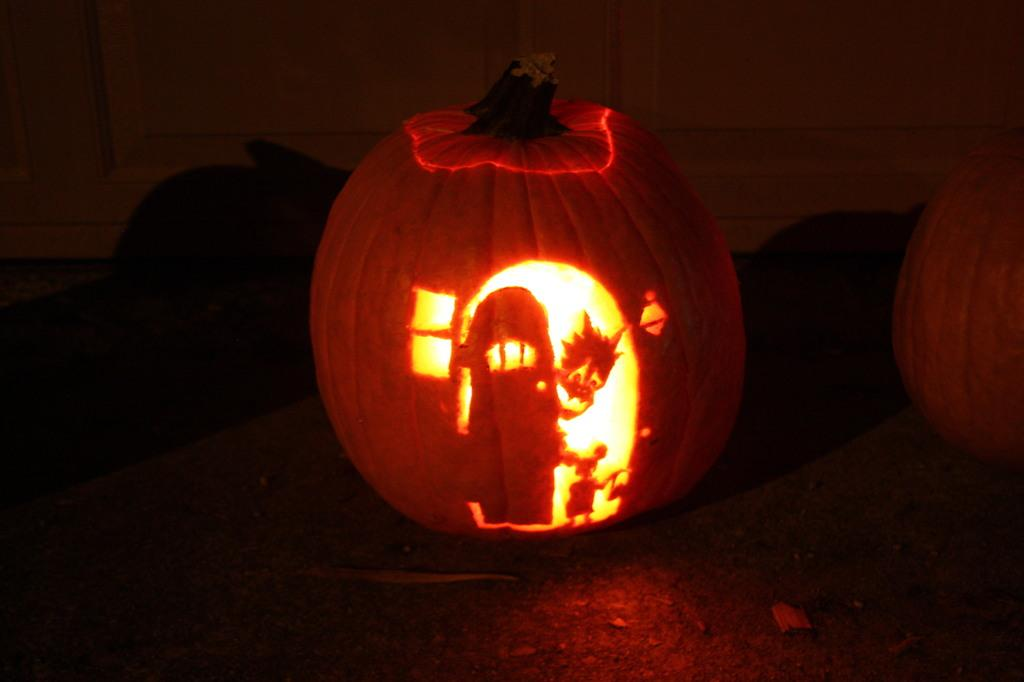What is on the table in the image? There is a hand-carved pumpkin with a light in it on a table. Are there any other pumpkins in the image? Yes, there is another pumpkin beside the hand-carved pumpkin. What type of cheese is draped over the veil of the stick in the image? There is no cheese, veil, or stick present in the image. 